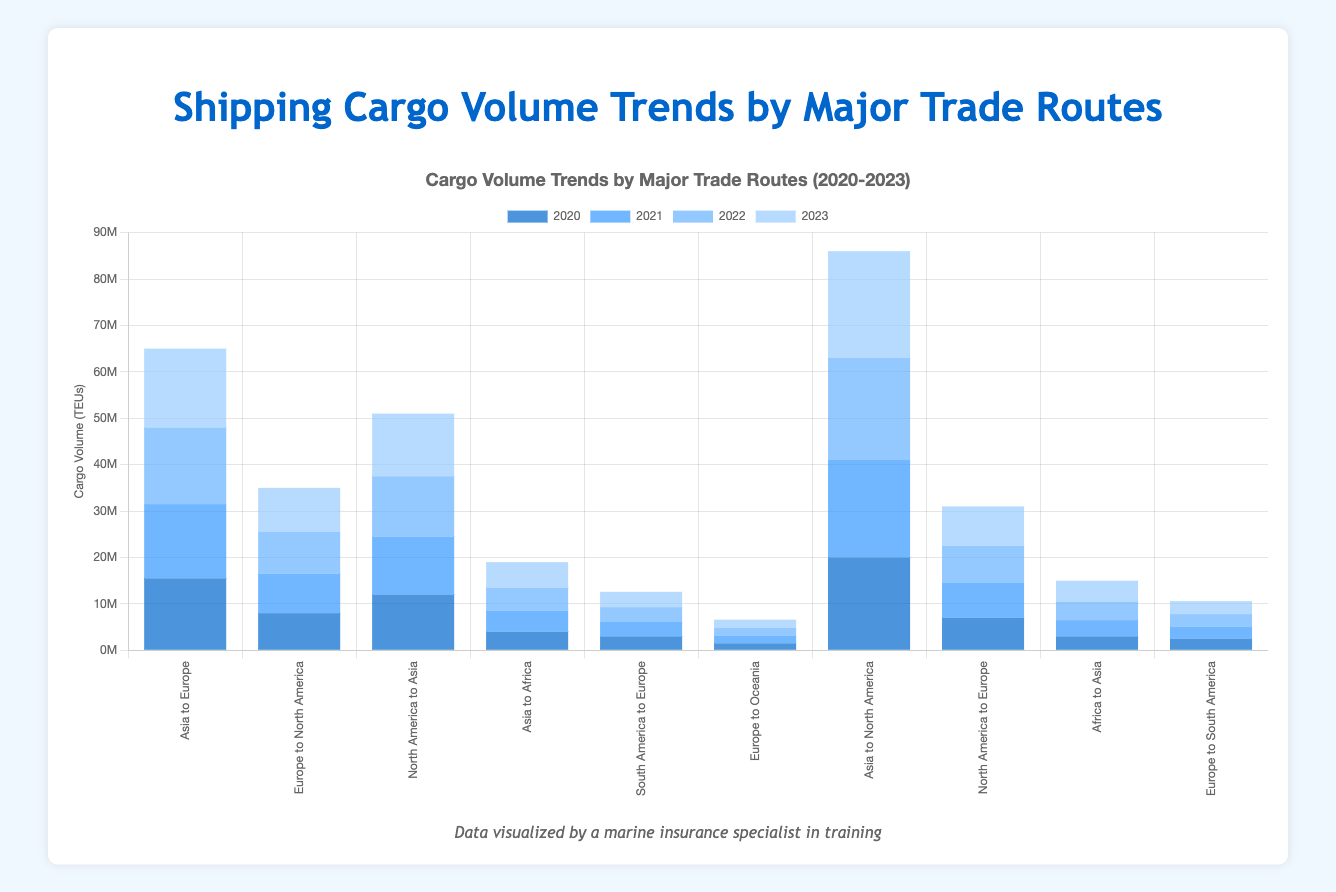Which trade route had the highest cargo volume in 2023? The bar representing "Asia to North America" in 2023 is the tallest, indicating it had the highest cargo volume.
Answer: Asia to North America What is the total cargo volume from Asia to Africa for all years combined? Sum the cargo volumes from 2020 to 2023 for "Asia to Africa": 4000000 (2020) + 4500000 (2021) + 5000000 (2022) + 5500000 (2023) = 19000000.
Answer: 19000000 Which trade route experienced the largest increase in cargo volume from 2020 to 2023? Calculate the increase for each route and compare. "Asia to North America" saw an increase from 20000000 in 2020 to 23000000 in 2023, which is the largest increase of 3000000.
Answer: Asia to North America In 2022, which trade route had a lower cargo volume than "Europe to North America"? The cargo volume for "Europe to North America" in 2022 is 9000000. Compare this to other routes for the same year. Trade routes with lower volumes are "South America to Europe", "Europe to Oceania", "Africa to Asia", and "Europe to South America".
Answer: South America to Europe, Europe to Oceania, Africa to Asia, Europe to South America What is the average annual cargo volume for "North America to Europe" from 2020 to 2023? Calculate the total volume: 7000000 (2020) + 7500000 (2021) + 8000000 (2022) + 8500000 (2023) = 31000000. Then find the average: 31000000 / 4 = 7750000.
Answer: 7750000 Which year had the smallest cargo volume for "Asia to Europe"? Compare the cargo volumes for "Asia to Europe" across the years: 15500000 (2020), 16000000 (2021), 16500000 (2022), 17000000 (2023). The smallest volume is in 2020.
Answer: 2020 What is the combined cargo volume for all trade routes in 2021? Sum the cargo volumes for all trade routes in 2021: 16000000 + 8500000 + 12500000 + 4500000 + 3100000 + 1600000 + 21000000 + 7500000 + 3500000 + 2600000 = 83000000.
Answer: 83000000 